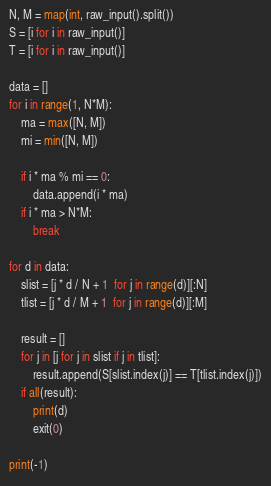Convert code to text. <code><loc_0><loc_0><loc_500><loc_500><_Python_>N, M = map(int, raw_input().split())
S = [i for i in raw_input()]
T = [i for i in raw_input()]

data = []
for i in range(1, N*M):
    ma = max([N, M])
    mi = min([N, M])

    if i * ma % mi == 0:
        data.append(i * ma)
    if i * ma > N*M:
        break

for d in data:
    slist = [j * d / N + 1  for j in range(d)][:N]
    tlist = [j * d / M + 1  for j in range(d)][:M]

    result = []
    for j in [j for j in slist if j in tlist]:
        result.append(S[slist.index(j)] == T[tlist.index(j)])
    if all(result):
        print(d)
        exit(0)

print(-1)
</code> 